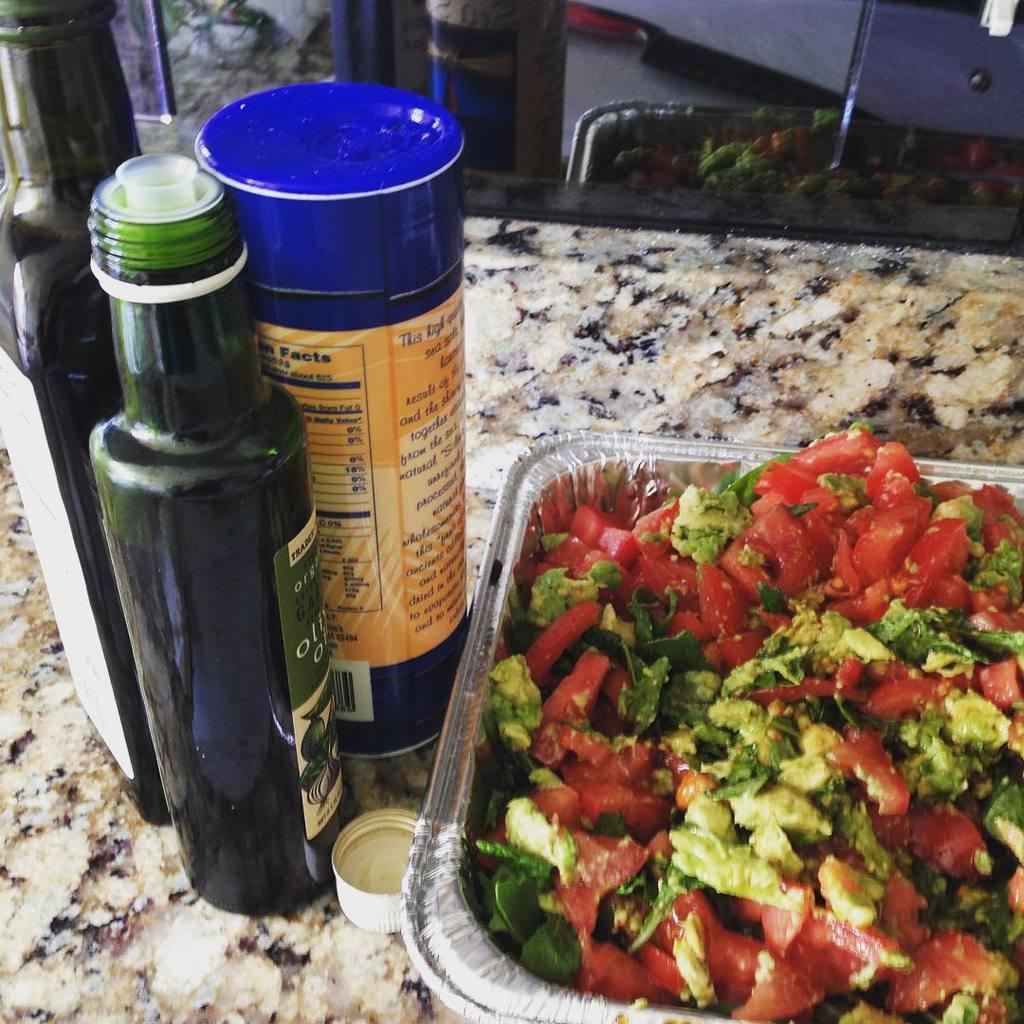In one or two sentences, can you explain what this image depicts? In this image we can see some bottles, a cap and a container with food is placed on the counter top. In the background, we can see a glass door. 